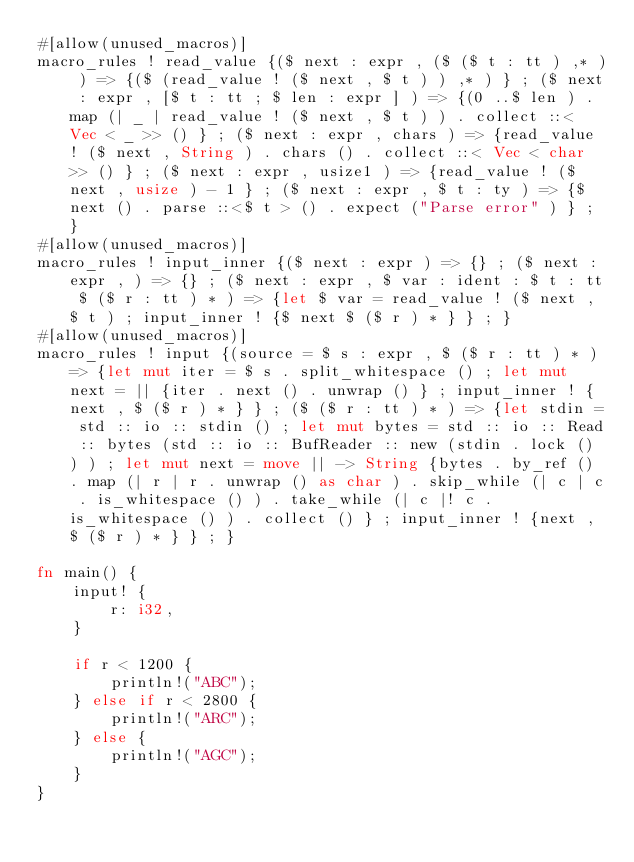Convert code to text. <code><loc_0><loc_0><loc_500><loc_500><_Rust_>#[allow(unused_macros)]
macro_rules ! read_value {($ next : expr , ($ ($ t : tt ) ,* ) ) => {($ (read_value ! ($ next , $ t ) ) ,* ) } ; ($ next : expr , [$ t : tt ; $ len : expr ] ) => {(0 ..$ len ) . map (| _ | read_value ! ($ next , $ t ) ) . collect ::< Vec < _ >> () } ; ($ next : expr , chars ) => {read_value ! ($ next , String ) . chars () . collect ::< Vec < char >> () } ; ($ next : expr , usize1 ) => {read_value ! ($ next , usize ) - 1 } ; ($ next : expr , $ t : ty ) => {$ next () . parse ::<$ t > () . expect ("Parse error" ) } ; }
#[allow(unused_macros)]
macro_rules ! input_inner {($ next : expr ) => {} ; ($ next : expr , ) => {} ; ($ next : expr , $ var : ident : $ t : tt $ ($ r : tt ) * ) => {let $ var = read_value ! ($ next , $ t ) ; input_inner ! {$ next $ ($ r ) * } } ; }
#[allow(unused_macros)]
macro_rules ! input {(source = $ s : expr , $ ($ r : tt ) * ) => {let mut iter = $ s . split_whitespace () ; let mut next = || {iter . next () . unwrap () } ; input_inner ! {next , $ ($ r ) * } } ; ($ ($ r : tt ) * ) => {let stdin = std :: io :: stdin () ; let mut bytes = std :: io :: Read :: bytes (std :: io :: BufReader :: new (stdin . lock () ) ) ; let mut next = move || -> String {bytes . by_ref () . map (| r | r . unwrap () as char ) . skip_while (| c | c . is_whitespace () ) . take_while (| c |! c . is_whitespace () ) . collect () } ; input_inner ! {next , $ ($ r ) * } } ; }

fn main() {
    input! {
        r: i32,
    }

    if r < 1200 {
        println!("ABC");
    } else if r < 2800 {
        println!("ARC");
    } else {
        println!("AGC");
    }
}
</code> 